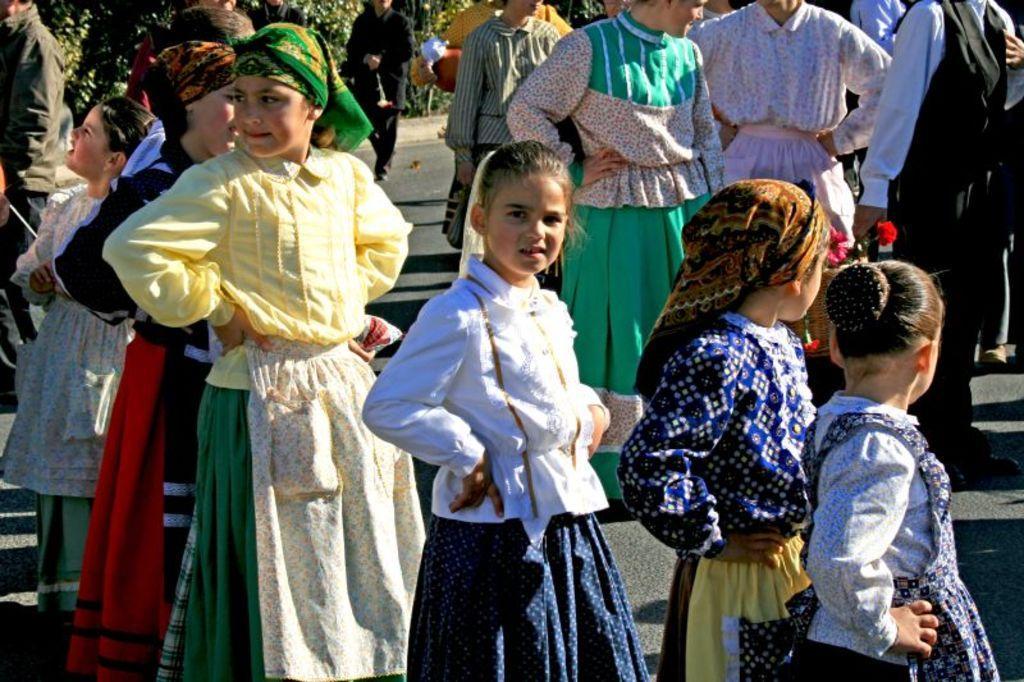In one or two sentences, can you explain what this image depicts? In this image we can see many people. Some are wearing scarf on the head. In the background there are trees. 